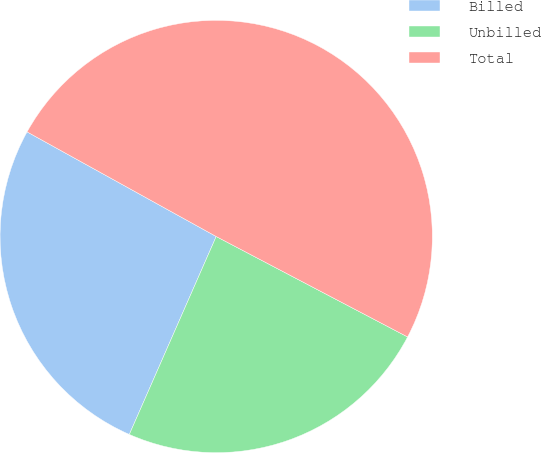<chart> <loc_0><loc_0><loc_500><loc_500><pie_chart><fcel>Billed<fcel>Unbilled<fcel>Total<nl><fcel>26.46%<fcel>23.89%<fcel>49.65%<nl></chart> 